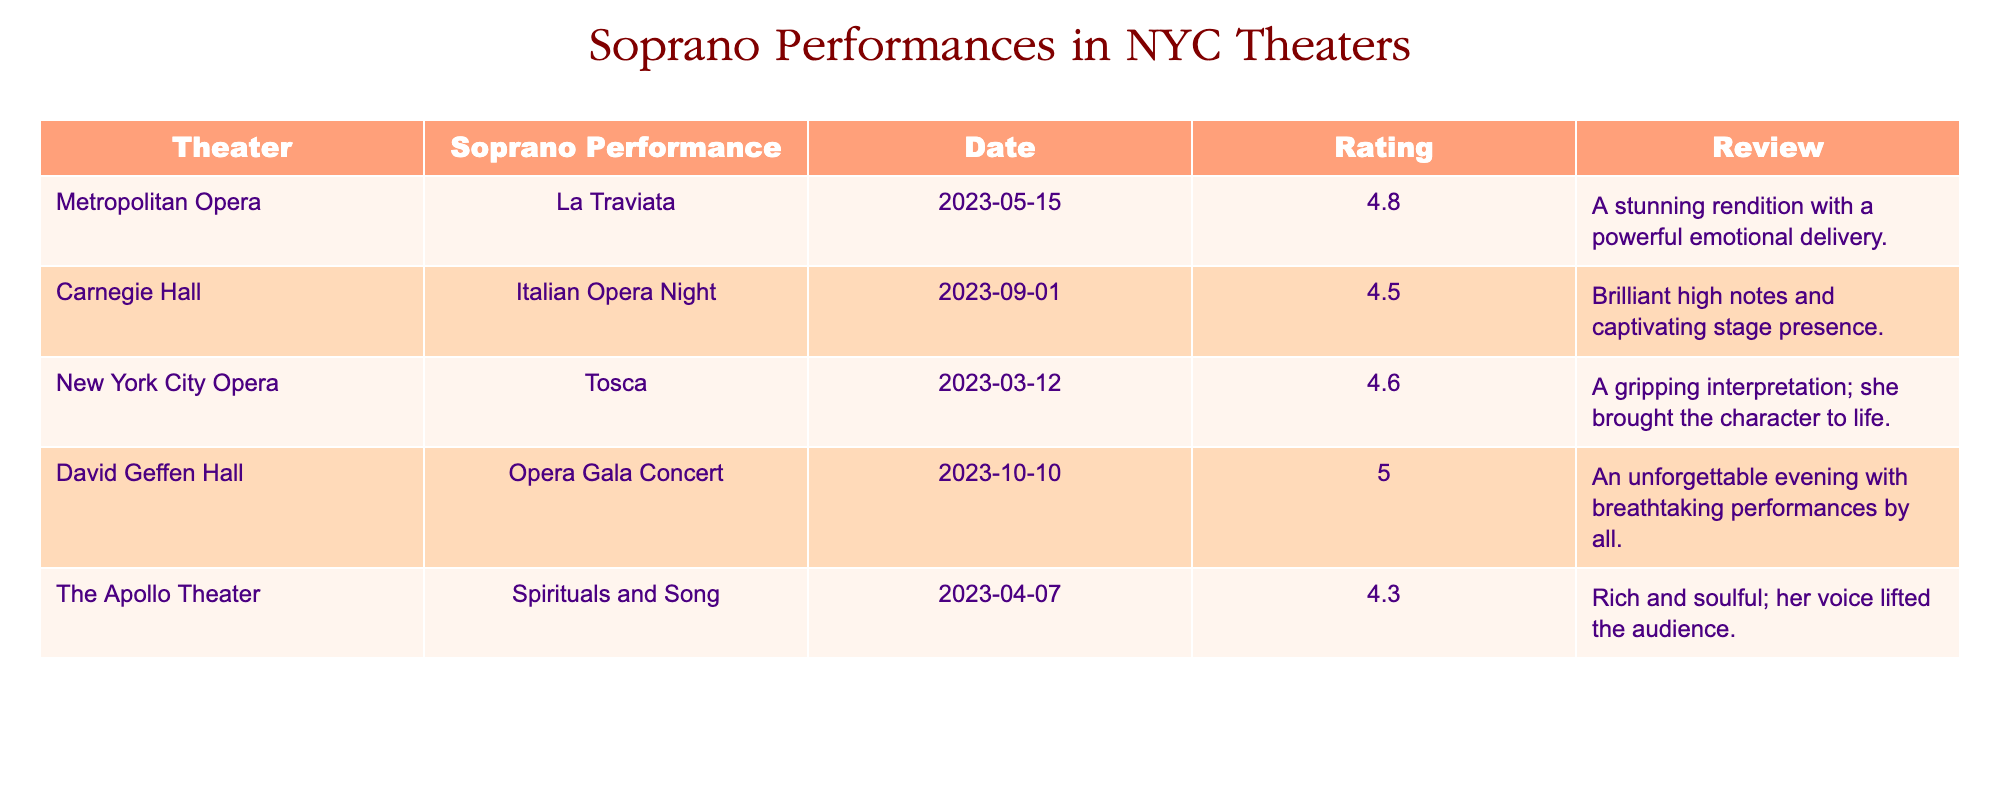What is the highest rating among the soprano performances? The table lists various ratings for each performance, with the highest being 5.0 for the "Opera Gala Concert" at David Geffen Hall.
Answer: 5.0 Which theater hosted the performance of "La Traviata"? The performance of "La Traviata" took place at the Metropolitan Opera, as indicated in the relevant row of the table.
Answer: Metropolitan Opera What was the rating for the performance of "Tosca"? The table shows that "Tosca" had a rating of 4.6. This value can be directly retrieved from the corresponding row.
Answer: 4.6 How many performances have a rating of 4.5 or higher? There are four performances with ratings of 4.5 or higher in the table: "La Traviata" (4.8), "Italian Opera Night" (4.5), "Tosca" (4.6), and "Opera Gala Concert" (5.0). Counting these gives us four performances.
Answer: 4 Is there a performance at Carnegie Hall? Yes, the table indicates that there was a performance titled "Italian Opera Night" at Carnegie Hall.
Answer: Yes What is the average rating of performances at theaters with names containing "Opera"? The ratings for performances at theaters containing "Opera" are: New York City Opera (4.6) and Metropolitan Opera (4.8). The average is calculated by (4.6 + 4.8) / 2 = 4.7.
Answer: 4.7 Did the Apollo Theater have a higher rating than David Geffen Hall? The Apollo Theater's performance received a rating of 4.3, while David Geffen Hall's performance received a rating of 5.0. Therefore, the Apollo Theater's rating is not higher than David Geffen Hall's.
Answer: No What is the total number of theaters represented in the table? The table lists distinct theaters: Metropolitan Opera, Carnegie Hall, New York City Opera, David Geffen Hall, and Apollo Theater, totaling five different theaters.
Answer: 5 Which performance had the most positive review? The review for "Opera Gala Concert" at David Geffen Hall reads "An unforgettable evening with breathtaking performances by all," indicating it is the most positive review in terms of descriptive language.
Answer: Opera Gala Concert 